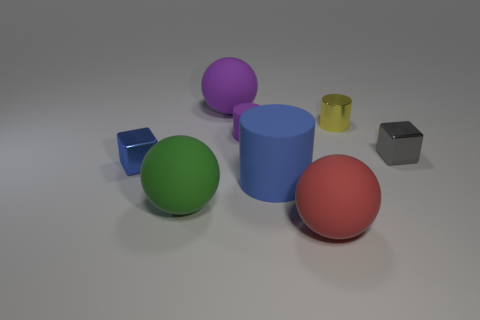Subtract all small cylinders. How many cylinders are left? 1 Subtract all gray blocks. How many blocks are left? 1 Add 2 blue blocks. How many objects exist? 10 Subtract all cylinders. How many objects are left? 5 Subtract 1 cylinders. How many cylinders are left? 2 Subtract all small cyan metallic objects. Subtract all blue shiny things. How many objects are left? 7 Add 5 large purple things. How many large purple things are left? 6 Add 2 big brown spheres. How many big brown spheres exist? 2 Subtract 1 blue blocks. How many objects are left? 7 Subtract all brown spheres. Subtract all blue cylinders. How many spheres are left? 3 